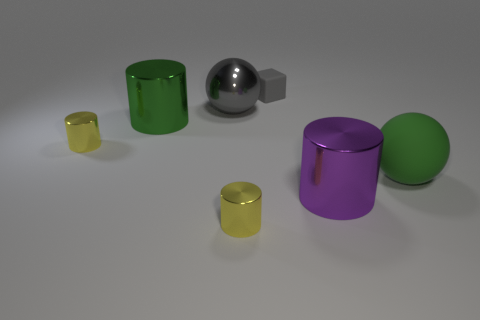Add 1 blue objects. How many objects exist? 8 Subtract all cyan blocks. How many yellow cylinders are left? 2 Subtract all purple metallic cylinders. How many cylinders are left? 3 Subtract all spheres. How many objects are left? 5 Subtract all purple cylinders. How many cylinders are left? 3 Subtract 2 cylinders. How many cylinders are left? 2 Subtract 1 gray blocks. How many objects are left? 6 Subtract all cyan blocks. Subtract all cyan cylinders. How many blocks are left? 1 Subtract all tiny metallic things. Subtract all yellow cylinders. How many objects are left? 3 Add 7 green matte balls. How many green matte balls are left? 8 